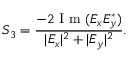<formula> <loc_0><loc_0><loc_500><loc_500>S _ { 3 } = \frac { - 2 I m ( E _ { x } E _ { y } ^ { * } ) } { | E _ { x } | ^ { 2 } + | E _ { y } | ^ { 2 } } .</formula> 